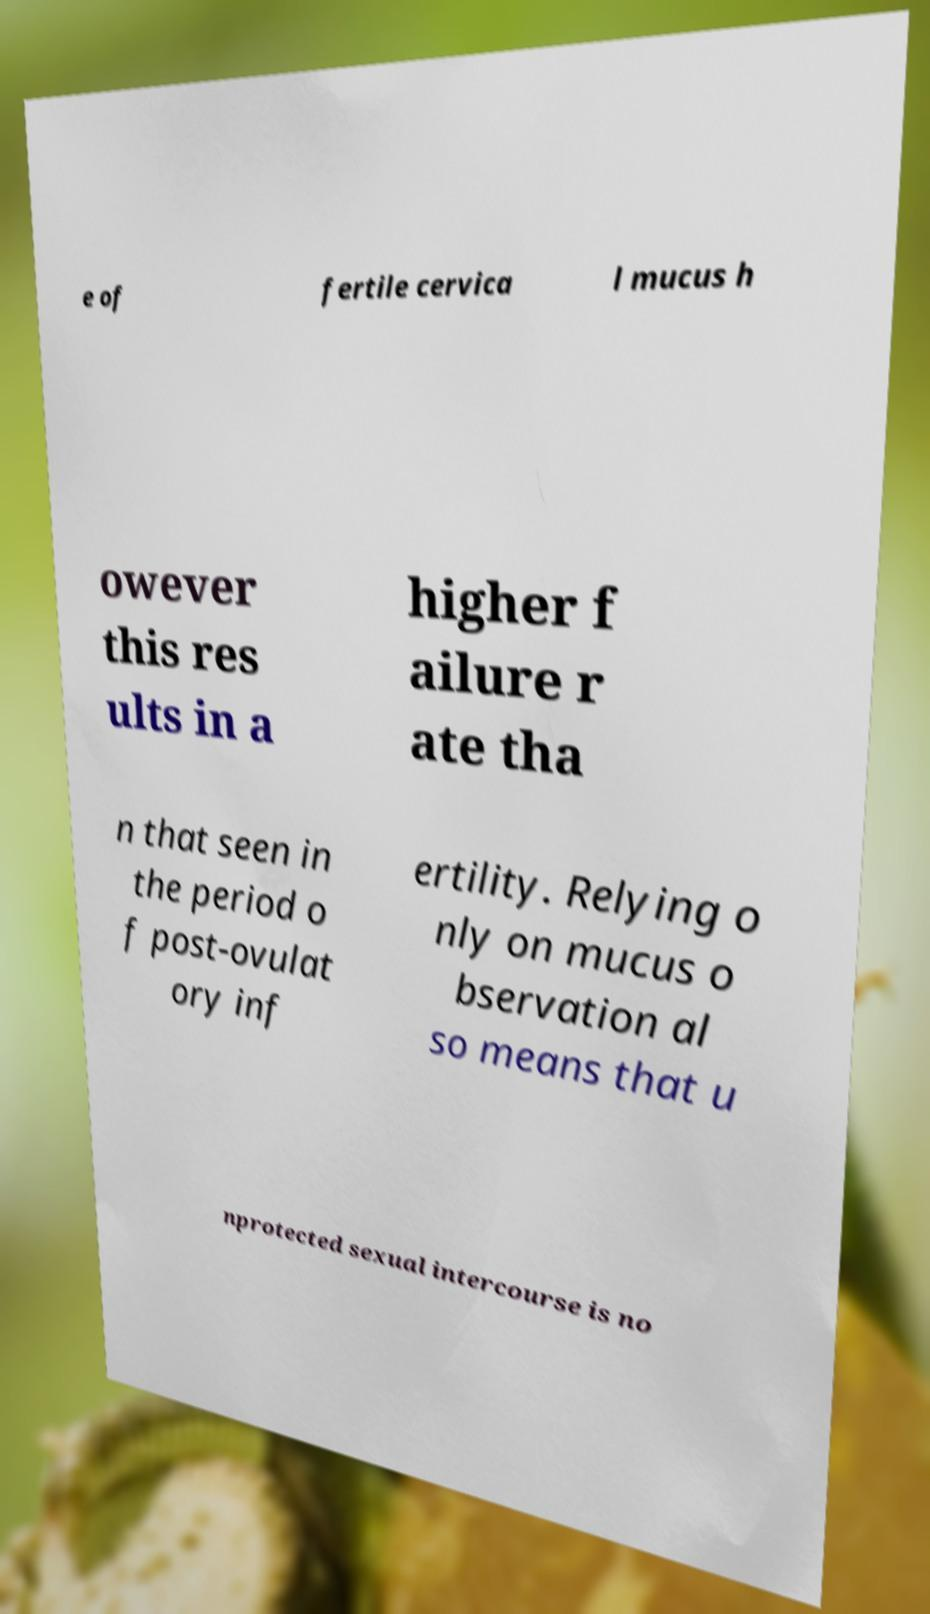I need the written content from this picture converted into text. Can you do that? e of fertile cervica l mucus h owever this res ults in a higher f ailure r ate tha n that seen in the period o f post-ovulat ory inf ertility. Relying o nly on mucus o bservation al so means that u nprotected sexual intercourse is no 